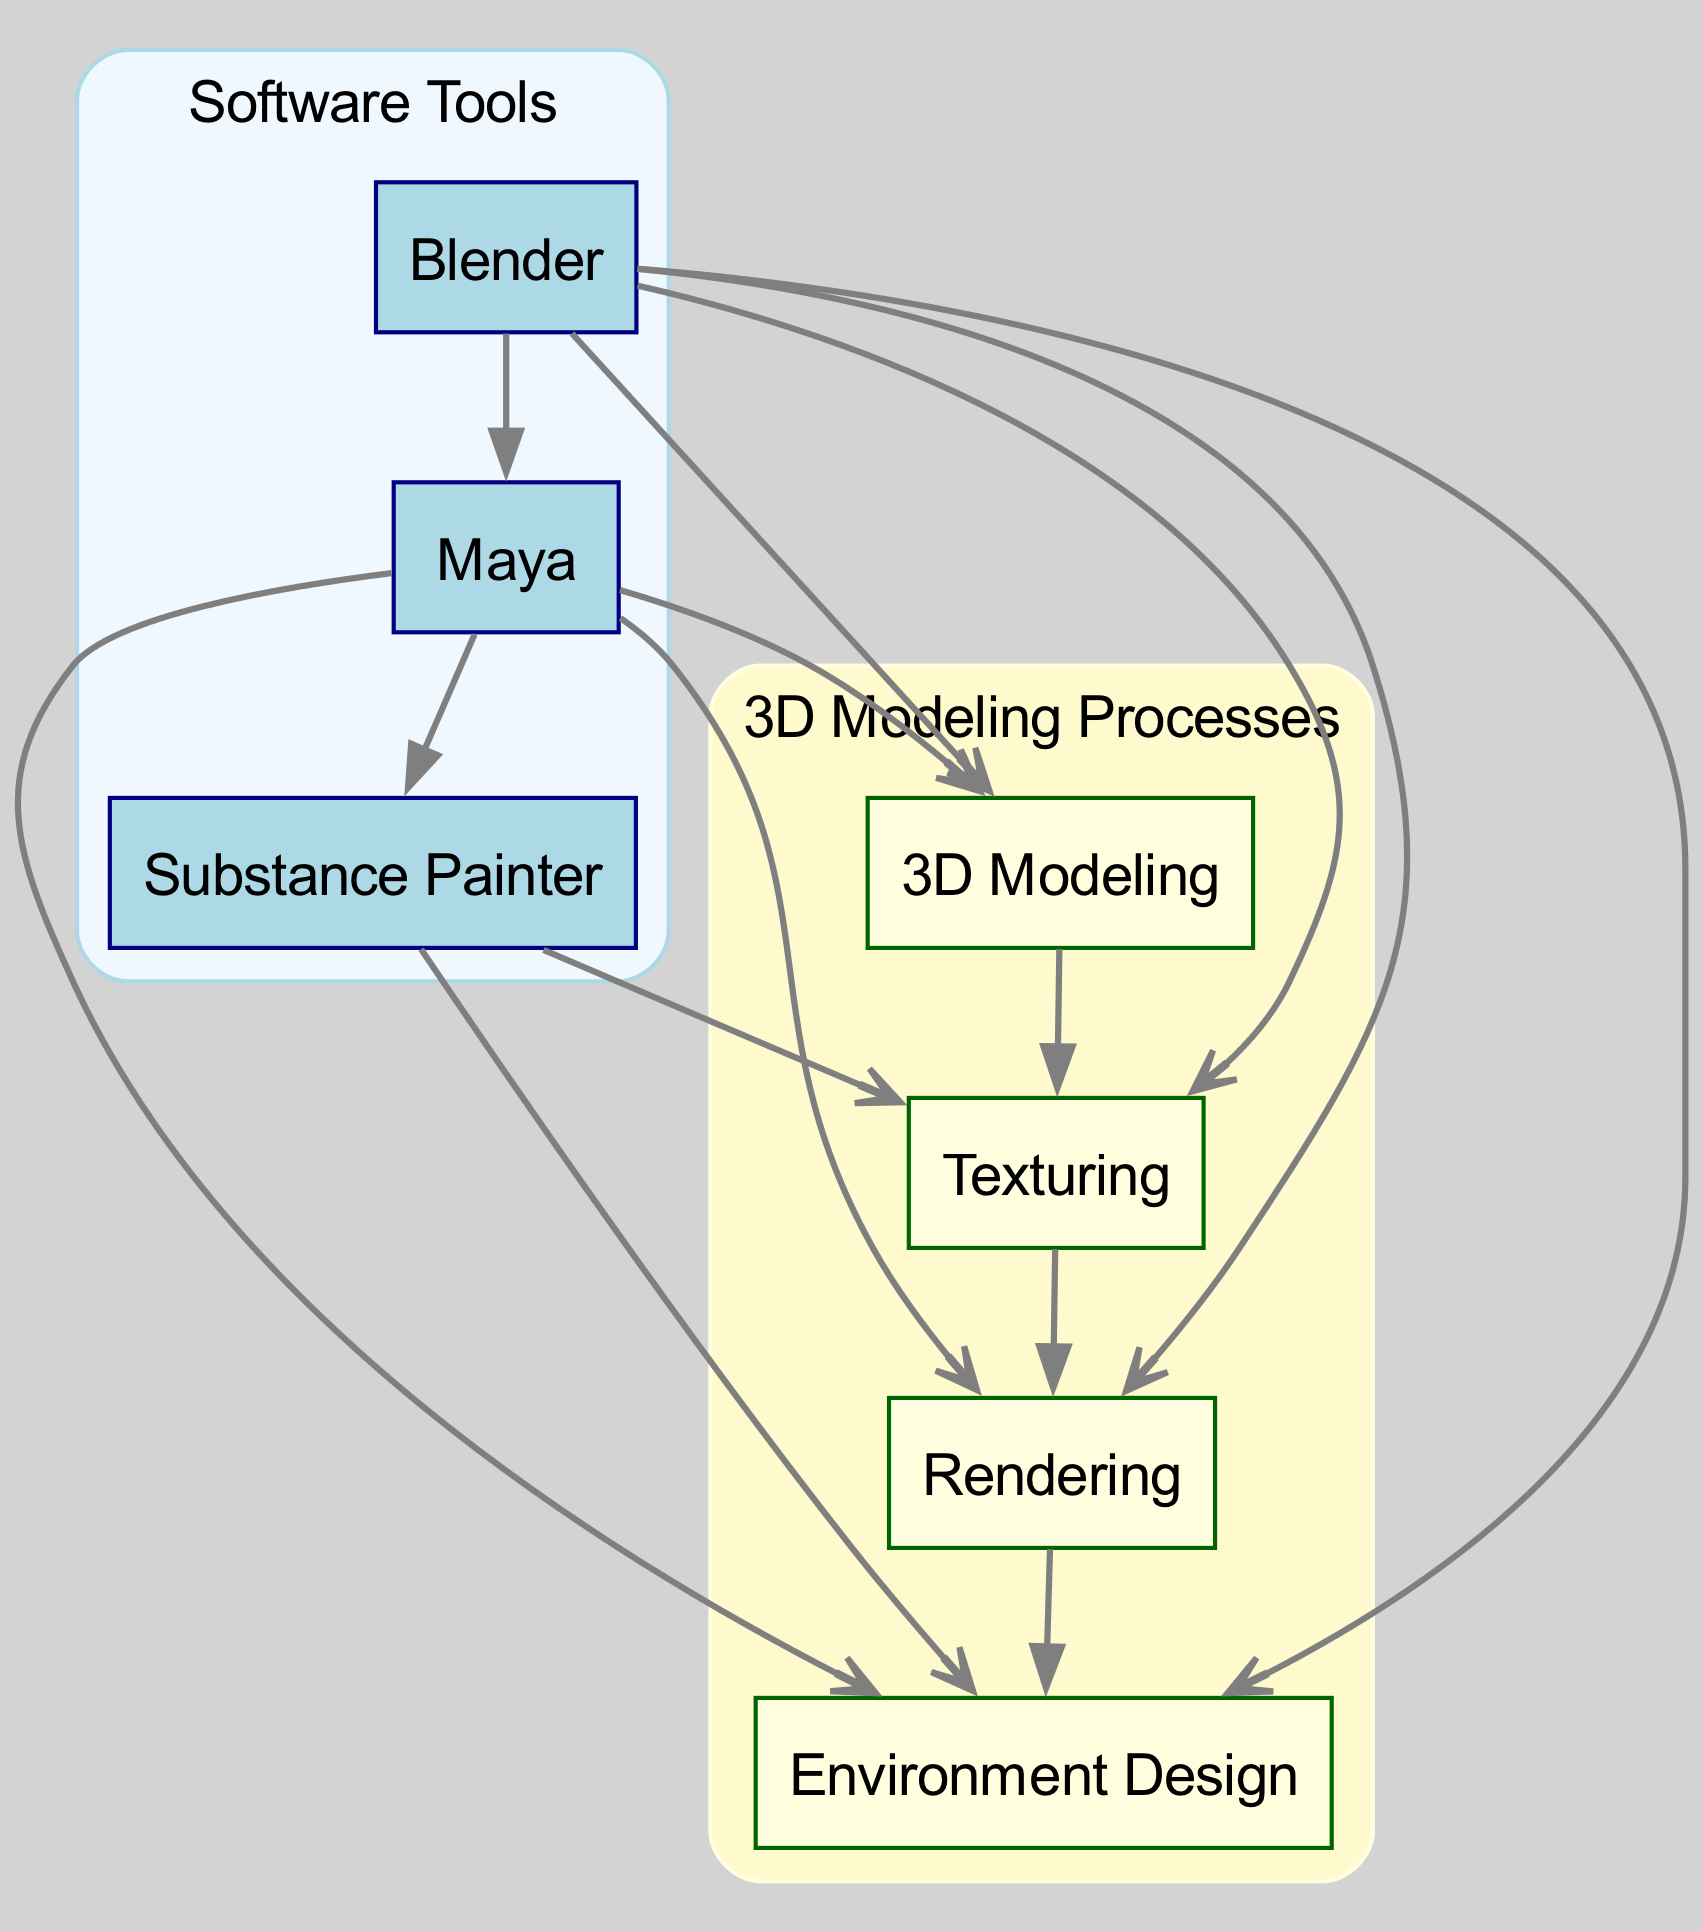What is the total number of nodes in the diagram? The diagram contains seven nodes, which are Blender, Maya, Substance Painter, 3D Modeling, Texturing, Rendering, and Environment Design.
Answer: 7 Which software tool is used for texturing? Substance Painter and Blender are the two tools in the diagram that play a role in the texturing process.
Answer: Substance Painter, Blender What is the output of the process "3D Modeling"? The process "3D Modeling" leads to the next stage in the workflow, which is Texturing.
Answer: Texturing How many edges connect Blender to the processes? Blender connects to three different processes: 3D Modeling, Texturing, and Environment Design, resulting in a total of three edges.
Answer: 3 Which software is connected to the Rendering process? The diagram shows that both Maya and Blender are connected to the Rendering process, indicating that they are used to render models.
Answer: Maya, Blender What is the relationship between Maya and Environment Design? Maya is directly connected to the Environment Design node, indicating that it is used in the environment design process.
Answer: Direct connection How many software tools are involved in Environment Design? Three software tools—Blender, Maya, and Substance Painter—are directly involved with the Environment Design process.
Answer: 3 Which process follows Texturing in the workflow? The workflow progresses from Texturing to the next process, which is Rendering.
Answer: Rendering How many software tools connect to the 3D Modeling process? Both Blender and Maya are software tools that connect to the 3D Modeling process, leading to a total of two connections.
Answer: 2 What does Substance Painter primarily contribute to? Substance Painter primarily contributes to the Texturing process according to the diagram.
Answer: Texturing 